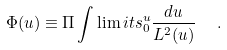<formula> <loc_0><loc_0><loc_500><loc_500>\Phi ( u ) \equiv \Pi \int \lim i t s _ { 0 } ^ { u } \frac { d u } { L ^ { 2 } ( u ) } \ \ .</formula> 